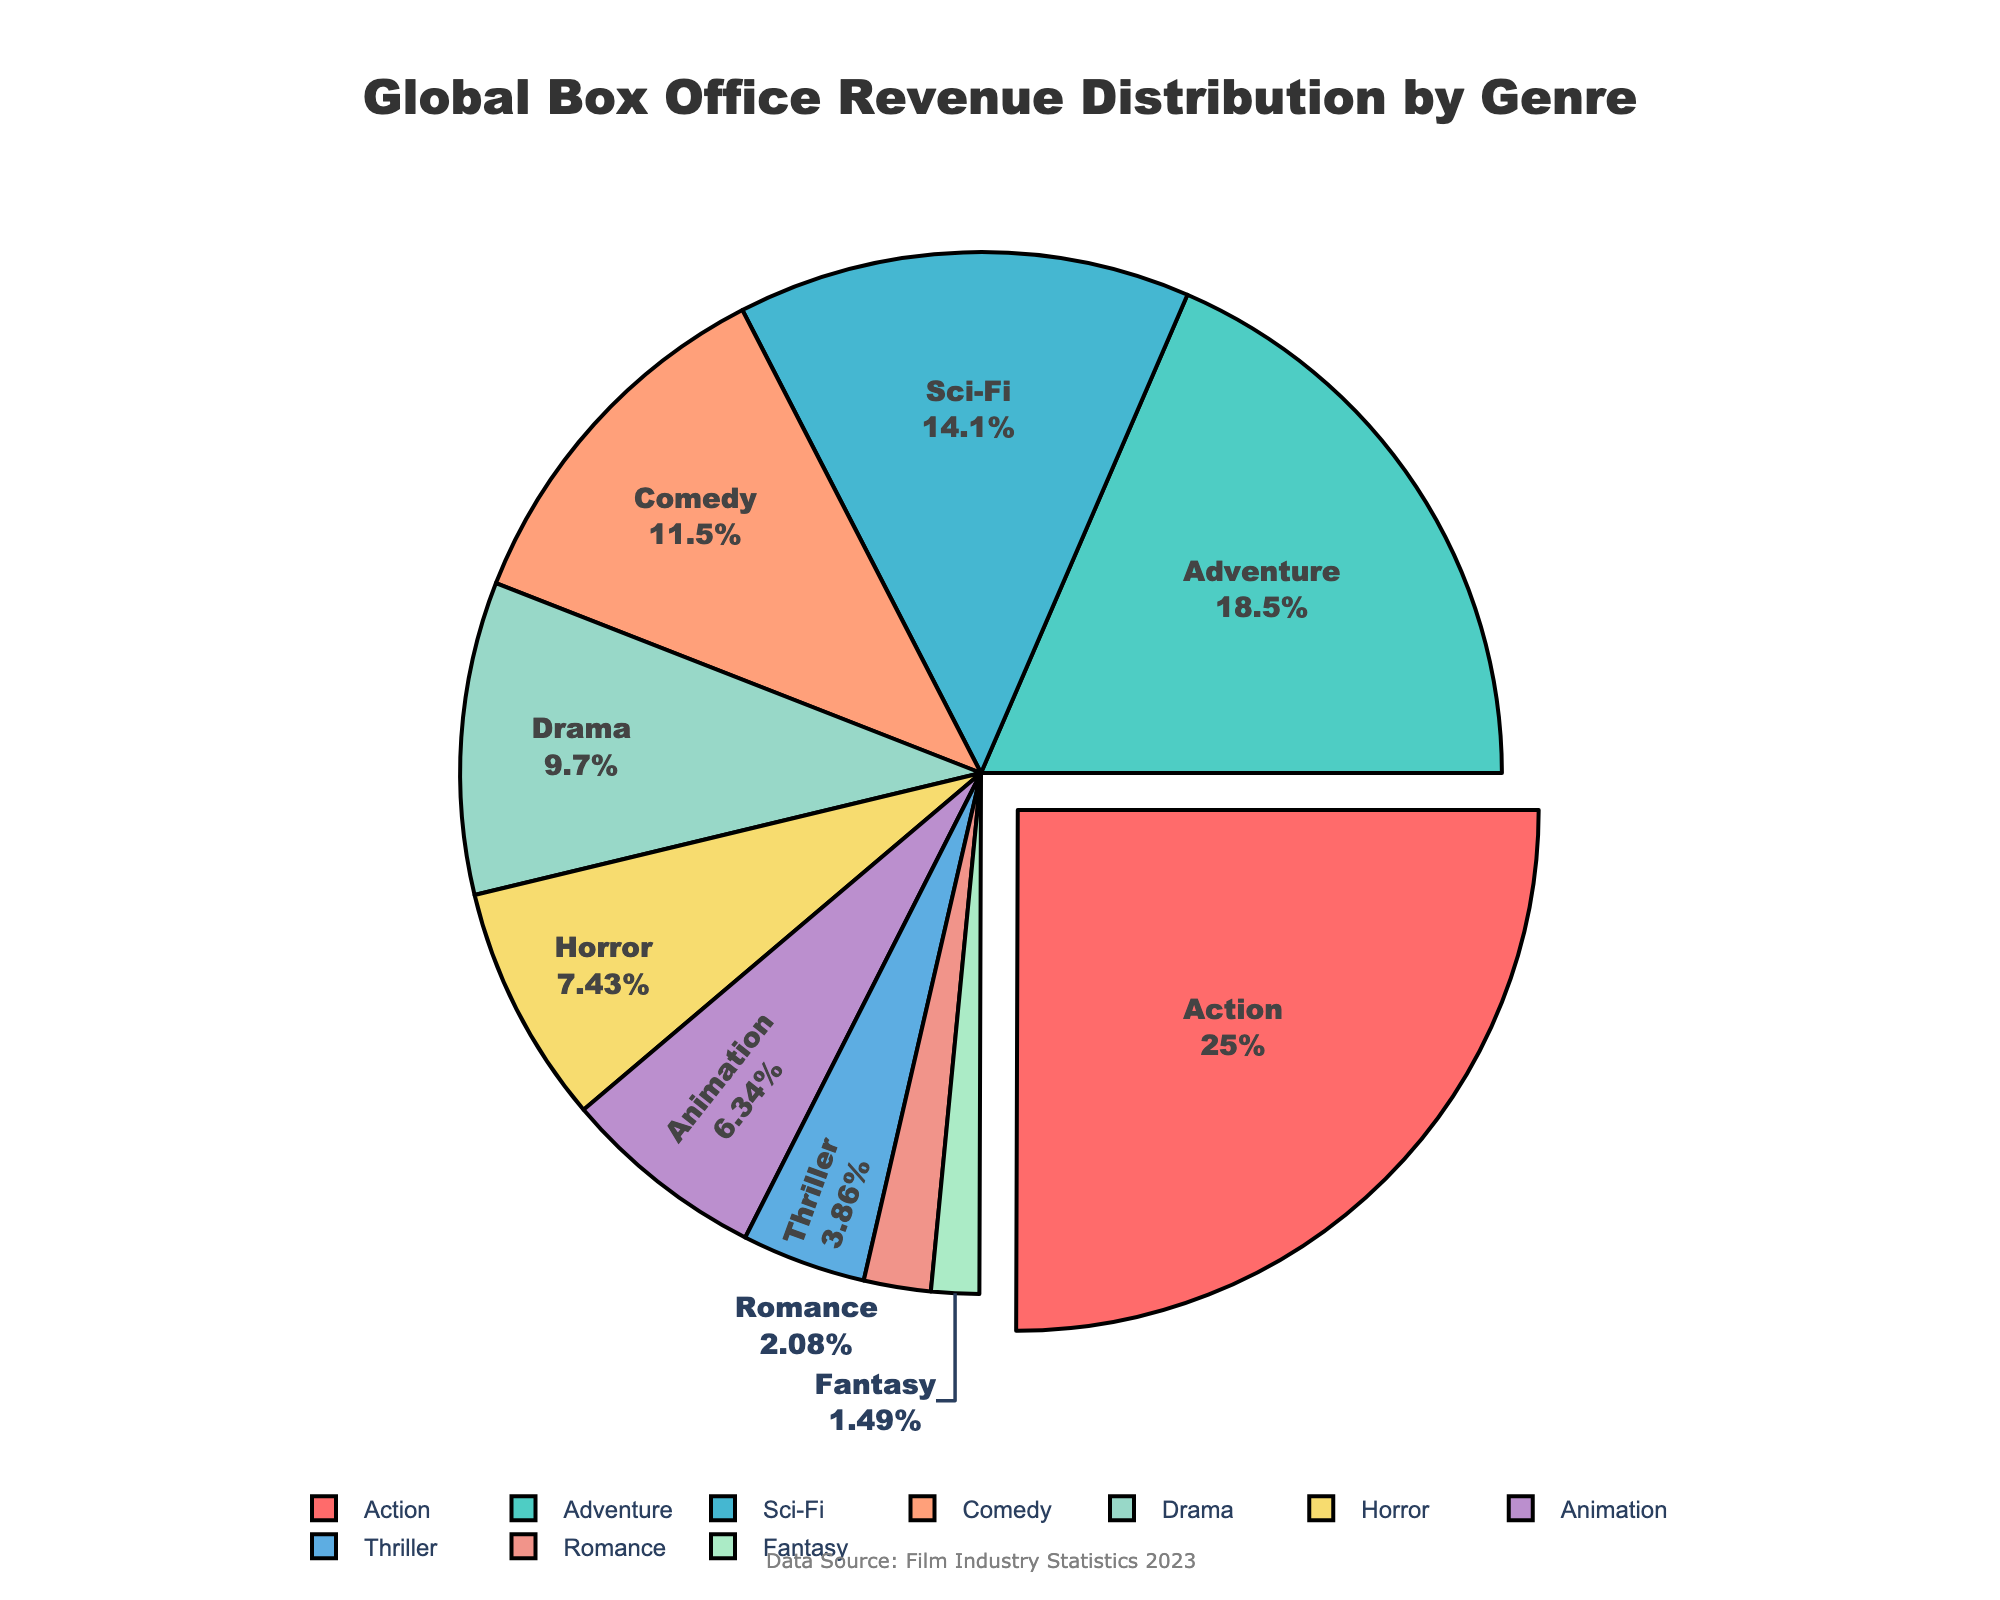What genre contributes the highest percentage to the global box office revenue? The pie chart shows that the Action genre is highlighted and pulled out slightly from the rest of the pie, indicating it contributes the most. The percentage value next to Action is 25.3%, which is the highest.
Answer: Action What is the combined revenue percentage of Adventure and Sci-Fi genres? The Adventure genre contributes 18.7% and the Sci-Fi genre contributes 14.2%. Summing these two percentages gives 18.7% + 14.2% = 32.9%.
Answer: 32.9% Is the revenue percentage of Comedy greater than that of Drama? Looking at the pie chart, Comedy has a 11.6% share while Drama has 9.8%. Since 11.6% is greater than 9.8%, Comedy has a greater revenue percentage.
Answer: Yes Which genre has a slightly lower revenue percentage than Horror? By observing the pie chart, Horror has a 7.5% share, and the next lower value is Animation with 6.4%.
Answer: Animation What is the total revenue percentage of genres that have less than 10% each? Adding the percentages of genres with less than 10%: Drama (9.8%), Horror (7.5%), Animation (6.4%), Thriller (3.9%), Romance (2.1%), and Fantasy (1.5%) gives us 9.8% + 7.5% + 6.4% + 3.9% + 2.1% + 1.5% = 31.2%.
Answer: 31.2% Which two genres combined have an equal or almost equal percentage to the Action genre? Action contributes 25.3%. Combining Adventure (18.7%) and Sci-Fi (14.2%) gives 18.7% + 14.2% = 32.9%, which is more. Combining Adventure (18.7%) and Comedy (11.6%) gives 18.7% + 11.6% = 30.3%, which is more. However, combining Sci-Fi (14.2%) and Comedy (11.6%) gives 14.2% + 11.6% = 25.8%, which is almost equal to 25.3%.
Answer: Sci-Fi and Comedy What genre has the smallest share in global box office revenue? According to the pie chart, the smallest segment represents Fantasy with a 1.5% share.
Answer: Fantasy Compare the revenue percentages of Action and Romance. The pie chart shows Action with 25.3% and Romance with 2.1%. 25.3% is significantly greater than 2.1%.
Answer: Action is greater What is the average revenue percentage of the top three genres? The top three genres are Action (25.3%), Adventure (18.7%), and Sci-Fi (14.2%). Their total percentage is 25.3% + 18.7% + 14.2% = 58.2%. The average is 58.2% / 3 = 19.4%.
Answer: 19.4% What percentage of the global box office revenue do genres Thriller, Romance, and Fantasy contribute together? The sum of the percentages for Thriller (3.9%), Romance (2.1%), and Fantasy (1.5%) is 3.9% + 2.1% + 1.5% = 7.5%.
Answer: 7.5% 